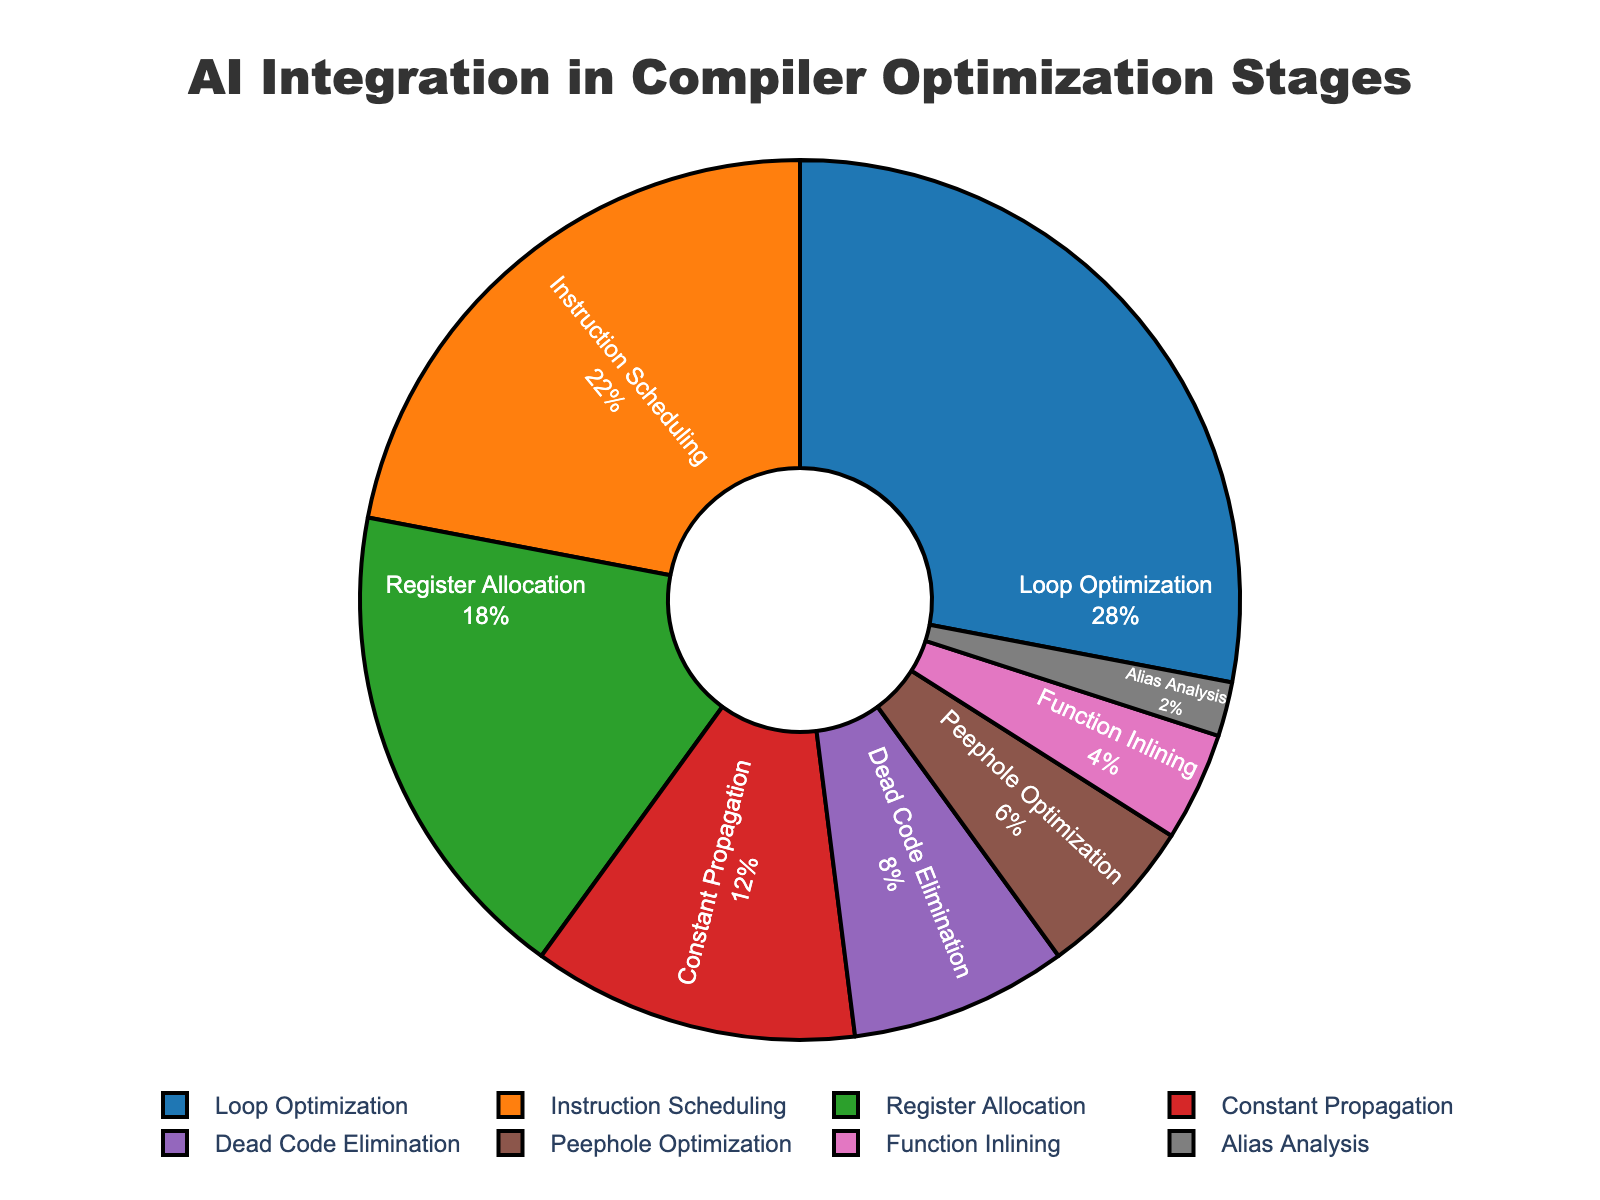Which stage has the highest proportion in benefiting from AI integration? The stage with the highest proportion is the one with the largest segment in the pie chart. Loop Optimization has the largest segment, making it the stage with the highest proportion.
Answer: Loop Optimization Which stage has the lowest proportion in benefiting from AI integration? The stage with the lowest proportion is the one with the smallest segment in the pie chart. Alias Analysis has the smallest segment, making it the stage with the lowest proportion.
Answer: Alias Analysis What is the combined proportion of Instruction Scheduling and Register Allocation? Add the proportions of Instruction Scheduling (22%) and Register Allocation (18%). 22% + 18% = 40%
Answer: 40% How much more does Loop Optimization benefit from AI integration compared to Dead Code Elimination? Find the difference in proportions between Loop Optimization (28%) and Dead Code Elimination (8%). 28% - 8% = 20%
Answer: 20% What is the median proportion of the stages benefiting from AI integration? Arrange the proportions in ascending order: 2%, 4%, 6%, 8%, 12%, 18%, 22%, 28%. The median is the average of the 4th and 5th values: (8% + 12%) / 2 = 10%
Answer: 10% Which two stages combined have a proportion approximately equal to that of Loop Optimization? Find two stages whose combined proportion is close to 28%. Instruction Scheduling (22%) and Function Inlining (4%) add up to 26%, which is closest to Loop Optimization's 28%.
Answer: Instruction Scheduling and Function Inlining By what percentage is Constant Propagation less than Loop Optimization? Calculate the difference in proportions between Constant Propagation (12%) and Loop Optimization (28%), then divide by Loop Optimization's proportion and multiply by 100. ((28% - 12%) / 28%) * 100 = 57.14%
Answer: 57.14% What proportion of the chart is made up of the two smallest categories combined? Add the smallest proportions: Alias Analysis (2%) and Function Inlining (4%). 2% + 4% = 6%
Answer: 6% Which stages have a proportion greater than 15%? Identify all stages with a proportion greater than 15% from the chart. Loop Optimization (28%), Instruction Scheduling (22%), and Register Allocation (18%) all meet this criterion.
Answer: Loop Optimization, Instruction Scheduling, Register Allocation 